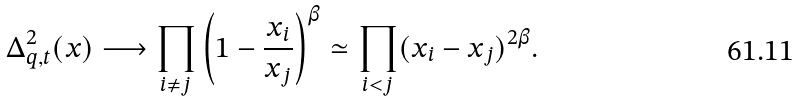Convert formula to latex. <formula><loc_0><loc_0><loc_500><loc_500>\Delta _ { q , t } ^ { 2 } ( x ) \longrightarrow \prod _ { i \not = j } \left ( 1 - \frac { x _ { i } } { x _ { j } } \right ) ^ { \beta } \simeq \prod _ { i < j } ( x _ { i } - x _ { j } ) ^ { 2 \beta } .</formula> 